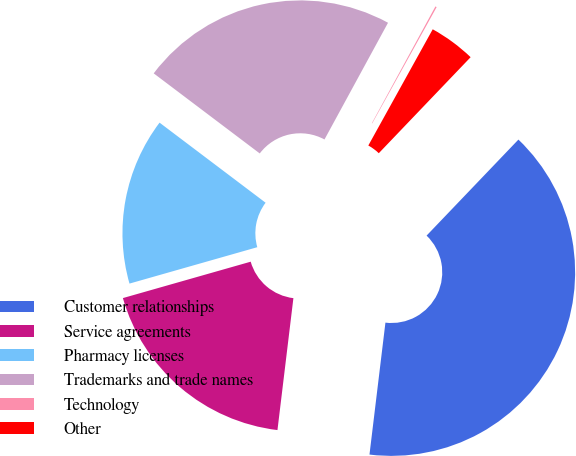Convert chart to OTSL. <chart><loc_0><loc_0><loc_500><loc_500><pie_chart><fcel>Customer relationships<fcel>Service agreements<fcel>Pharmacy licenses<fcel>Trademarks and trade names<fcel>Technology<fcel>Other<nl><fcel>39.77%<fcel>18.67%<fcel>14.71%<fcel>22.64%<fcel>0.12%<fcel>4.09%<nl></chart> 